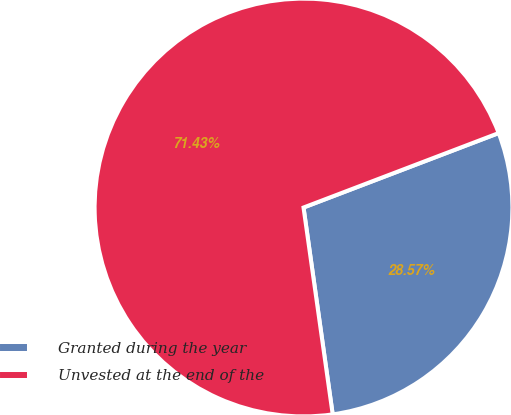Convert chart to OTSL. <chart><loc_0><loc_0><loc_500><loc_500><pie_chart><fcel>Granted during the year<fcel>Unvested at the end of the<nl><fcel>28.57%<fcel>71.43%<nl></chart> 